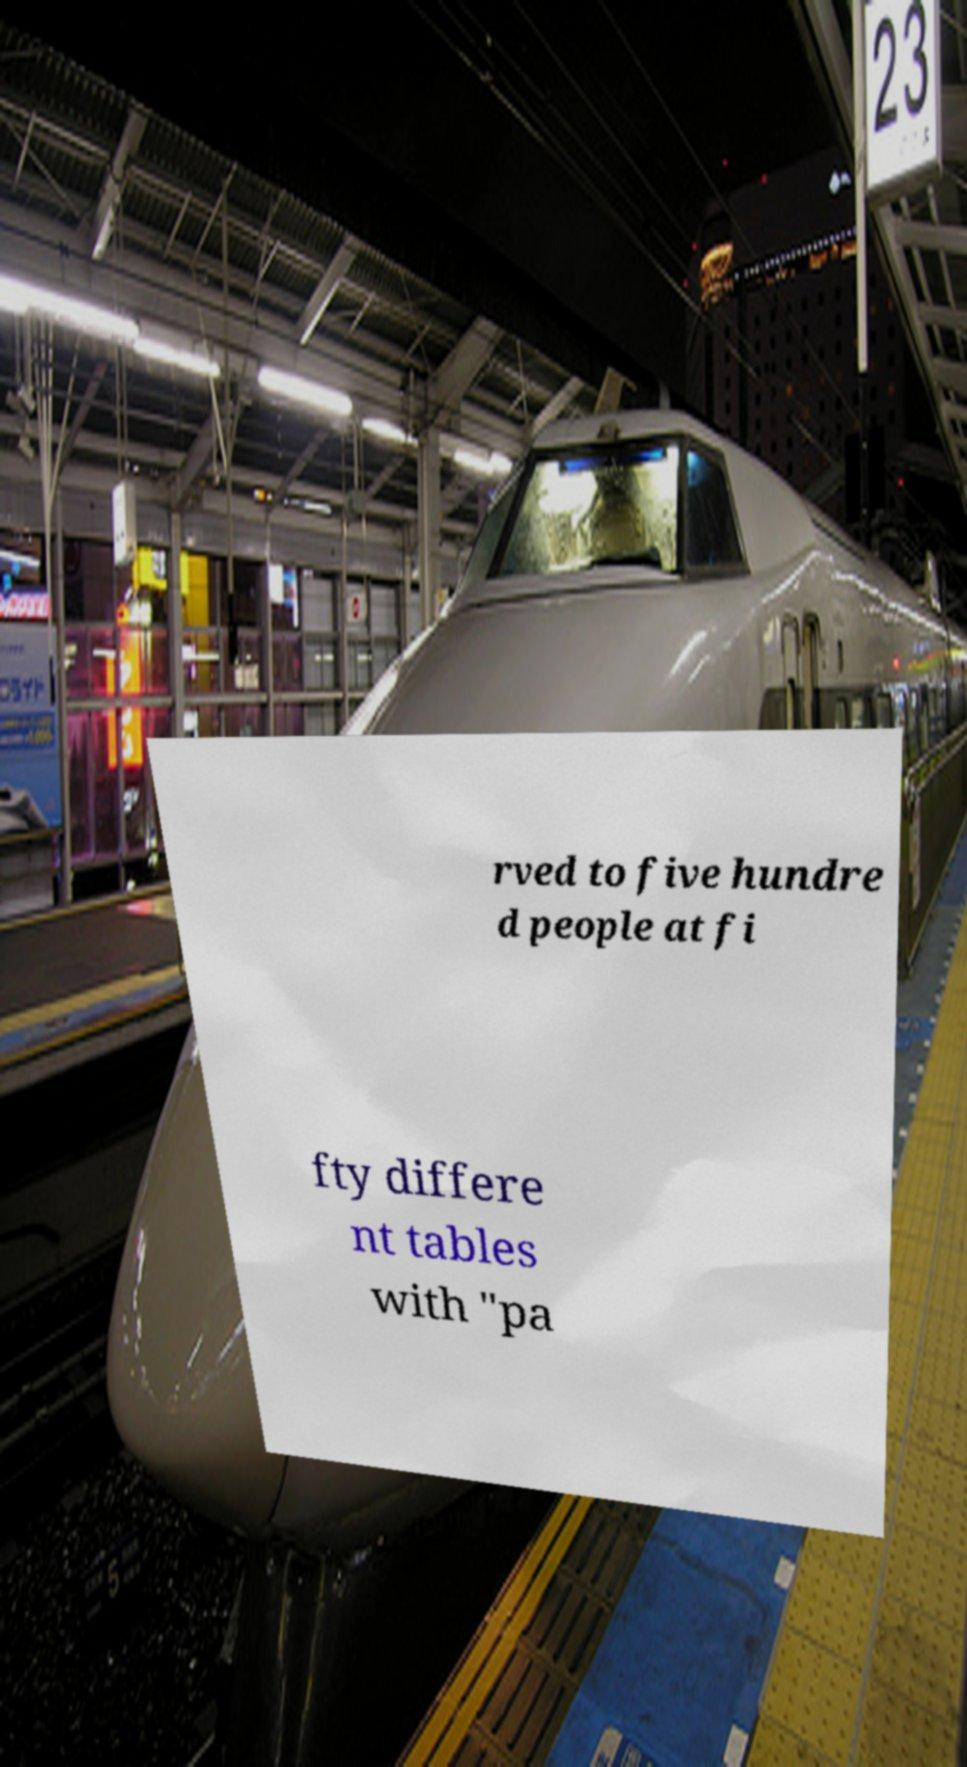There's text embedded in this image that I need extracted. Can you transcribe it verbatim? rved to five hundre d people at fi fty differe nt tables with "pa 